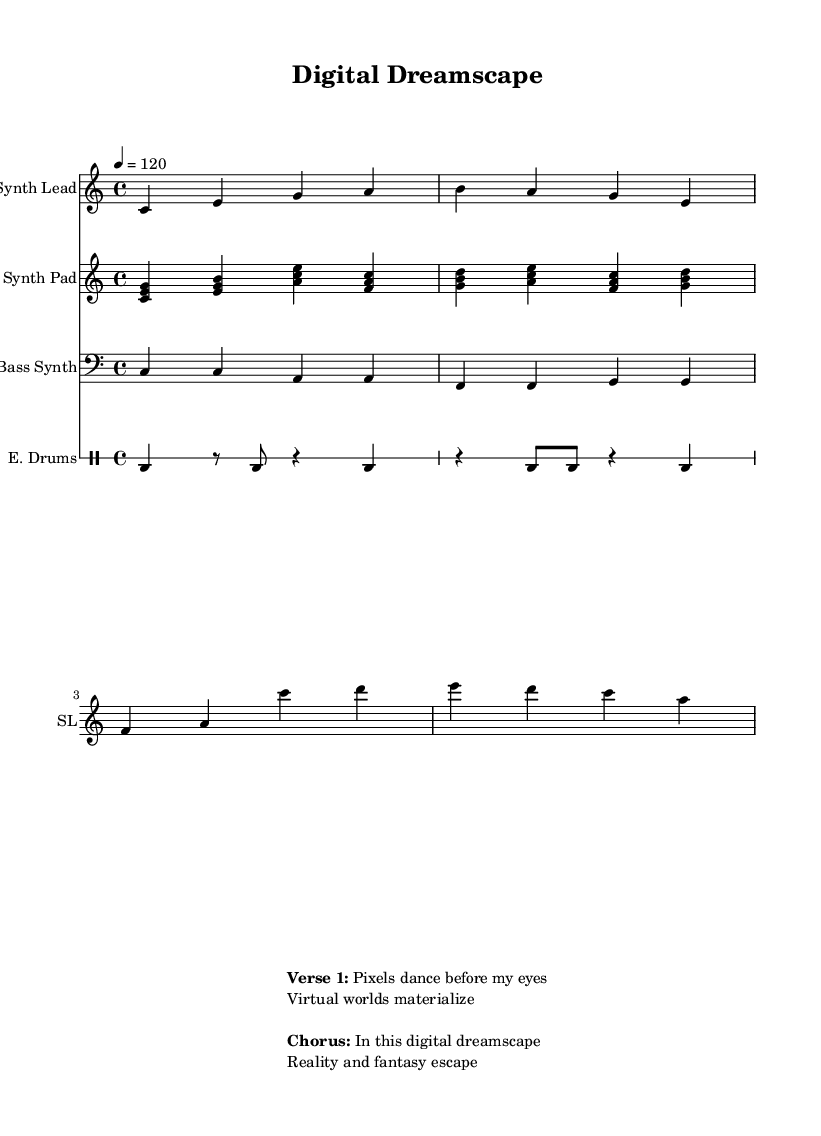What is the key signature of this music? The key signature is indicated at the beginning of the score. In this case, it shows C major, which has no sharps or flats.
Answer: C major What is the time signature of this music? The time signature is shown at the beginning of the score. It is 4/4, meaning there are four beats per measure and the quarter note gets one beat.
Answer: 4/4 What is the tempo marking for this piece? The tempo marking is specified in beats per minute. Here, it reads "4 = 120," meaning there are 120 beats in one minute.
Answer: 120 How many measures are in the synth lead part? By counting the groups of notes or symbols in the synth lead part, we observe that it comprises a total of 8 measures.
Answer: 8 What is the primary theme conveyed in the lyrics? The lyrics presented in the score express the idea of a digital dreamscape where virtual and real worlds intertwine, suggesting themes of escapism and technology.
Answer: Digital dreamscape How many different instrument parts are included in the score? By reviewing the score, we can identify four distinct parts: Synth Lead, Synth Pad, Bass Synth, and E. Drums. Therefore, there are four instrument parts.
Answer: 4 In what style is this song composed? The style can be inferred from the use of synthesizers and electronic drums, typical characteristics of synth-pop music. Thematically, it focuses on technology and virtual reality.
Answer: Synth-pop 